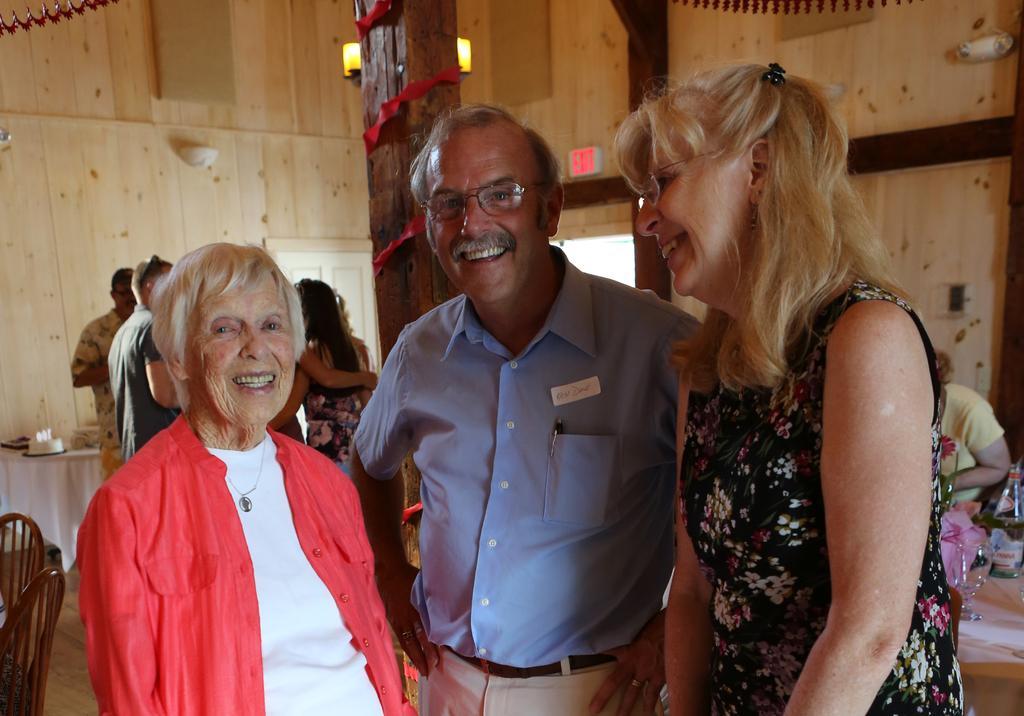Could you give a brief overview of what you see in this image? In the center of the image we can see persons standing on the floor. In the background we can see persons, table, chairs, cake, poles and wall. 